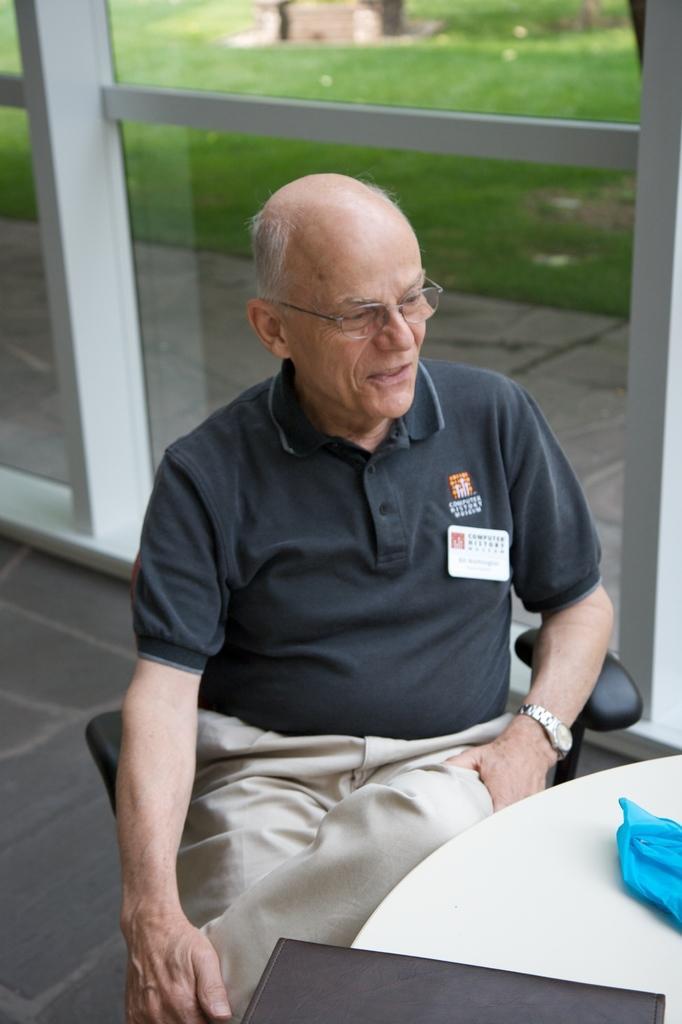Can you describe this image briefly? In the center of the image we can see one person is sitting and he is wearing glasses. In front of him, we can see a table. On the table, we can see one black color object and a blue color object. In the background there is a floor and glass. Through the glass, we can see the grass and some objects. 